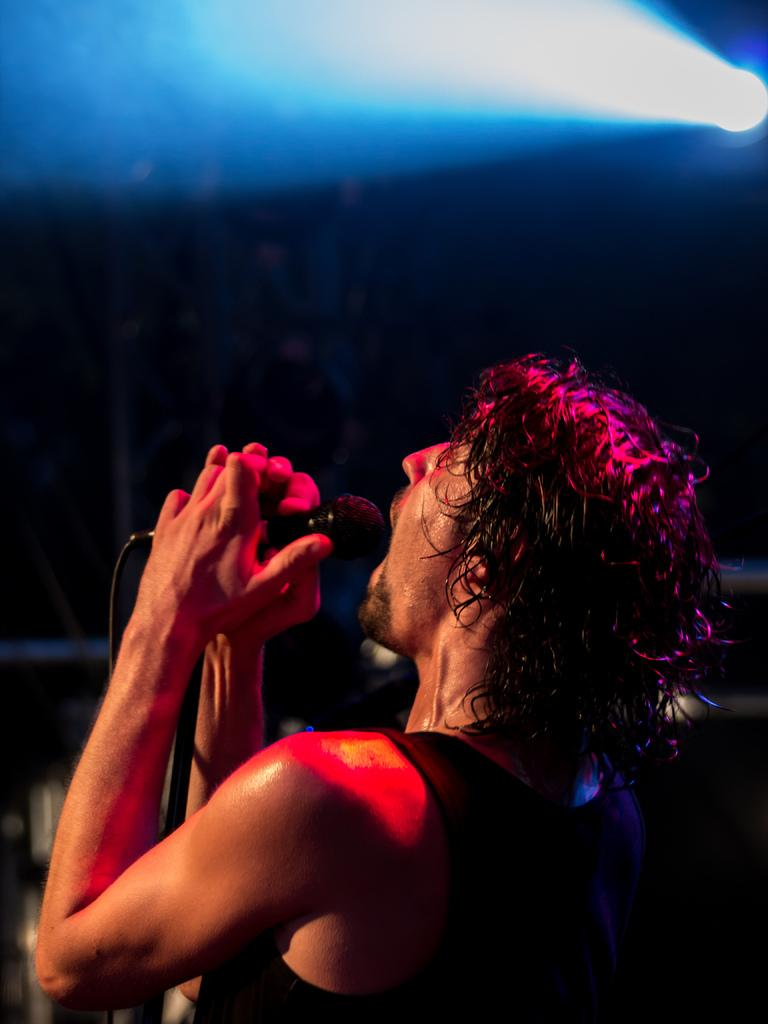Who is present in the image? There is a man in the image. What is the man doing in the image? The man is standing in the image. What object is the man holding in the image? The man is holding a microphone in the image. What can be seen at the top of the image? There is a light visible at the top of the image. What type of loaf is the man holding in the image? There is no loaf present in the image; the man is holding a microphone. 